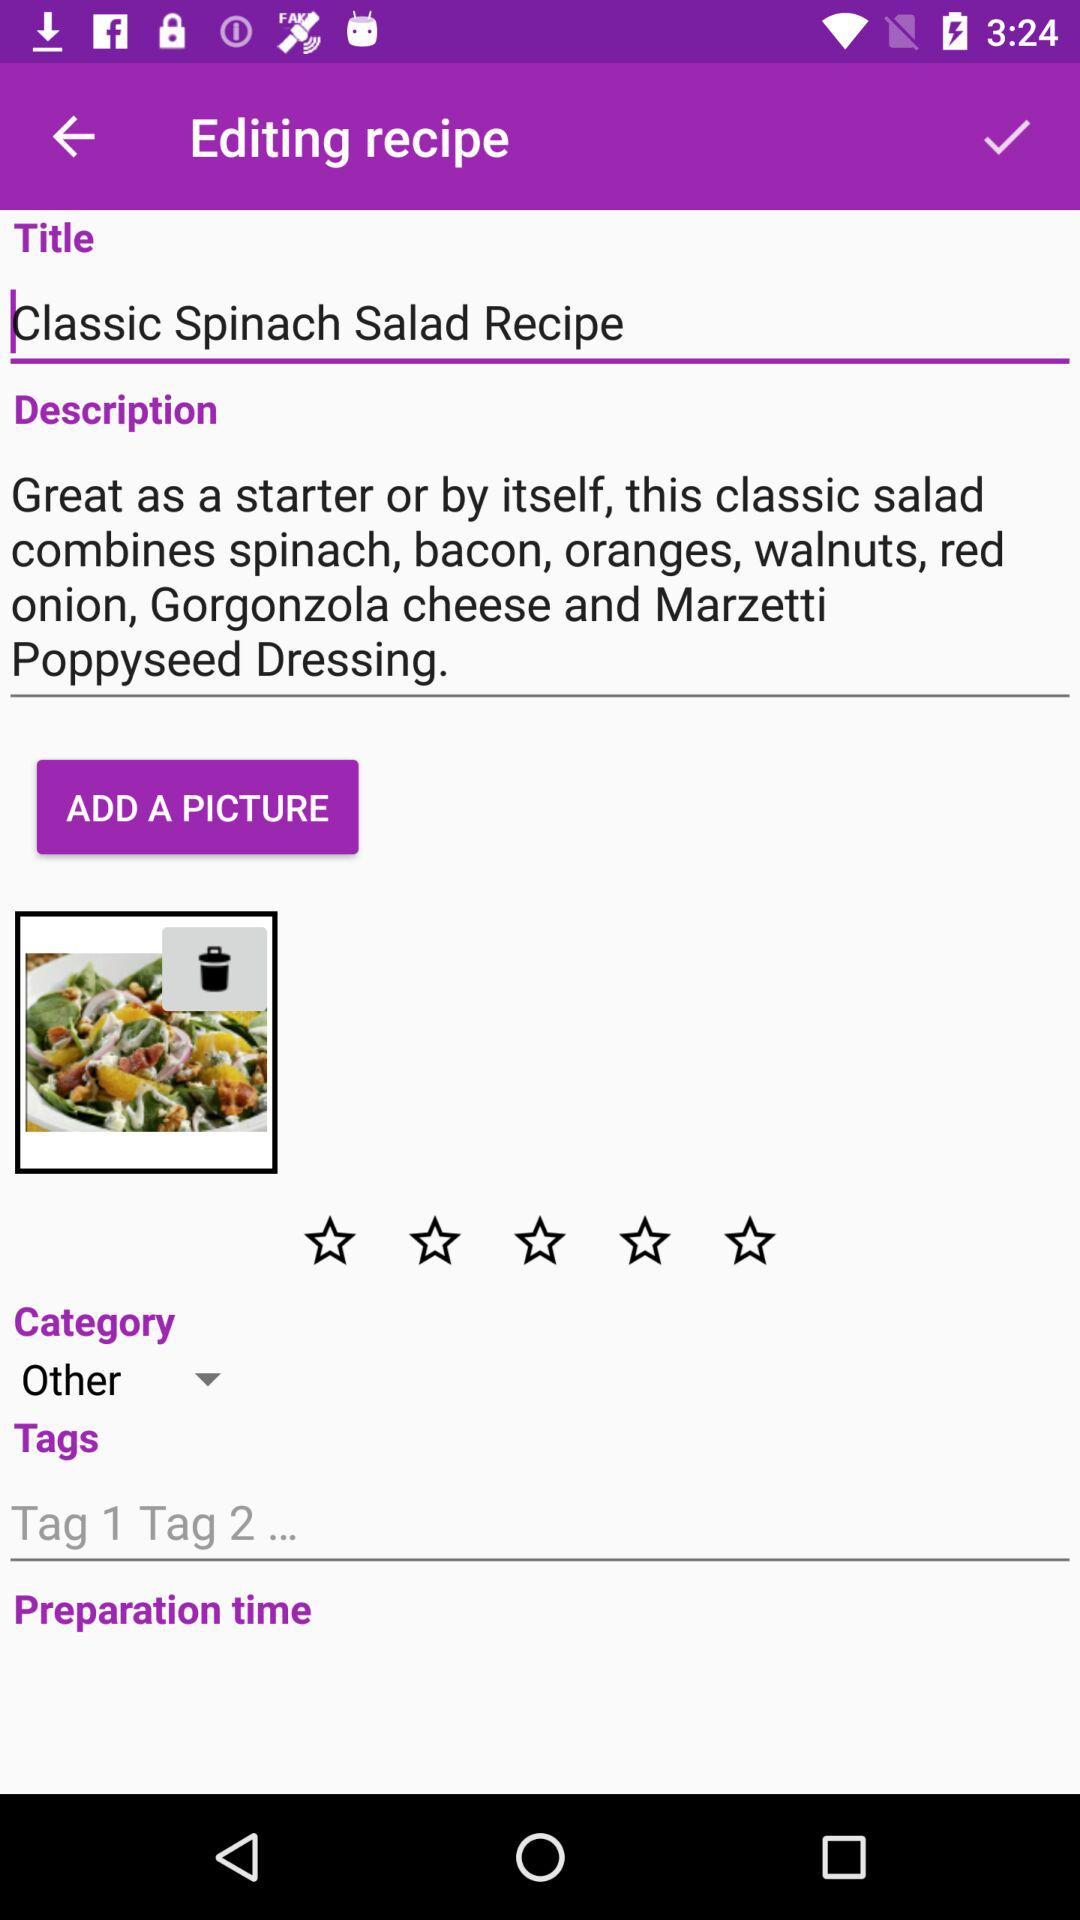What is the title of the recipe? The title is "Classic Spinach Salad Recipe". 